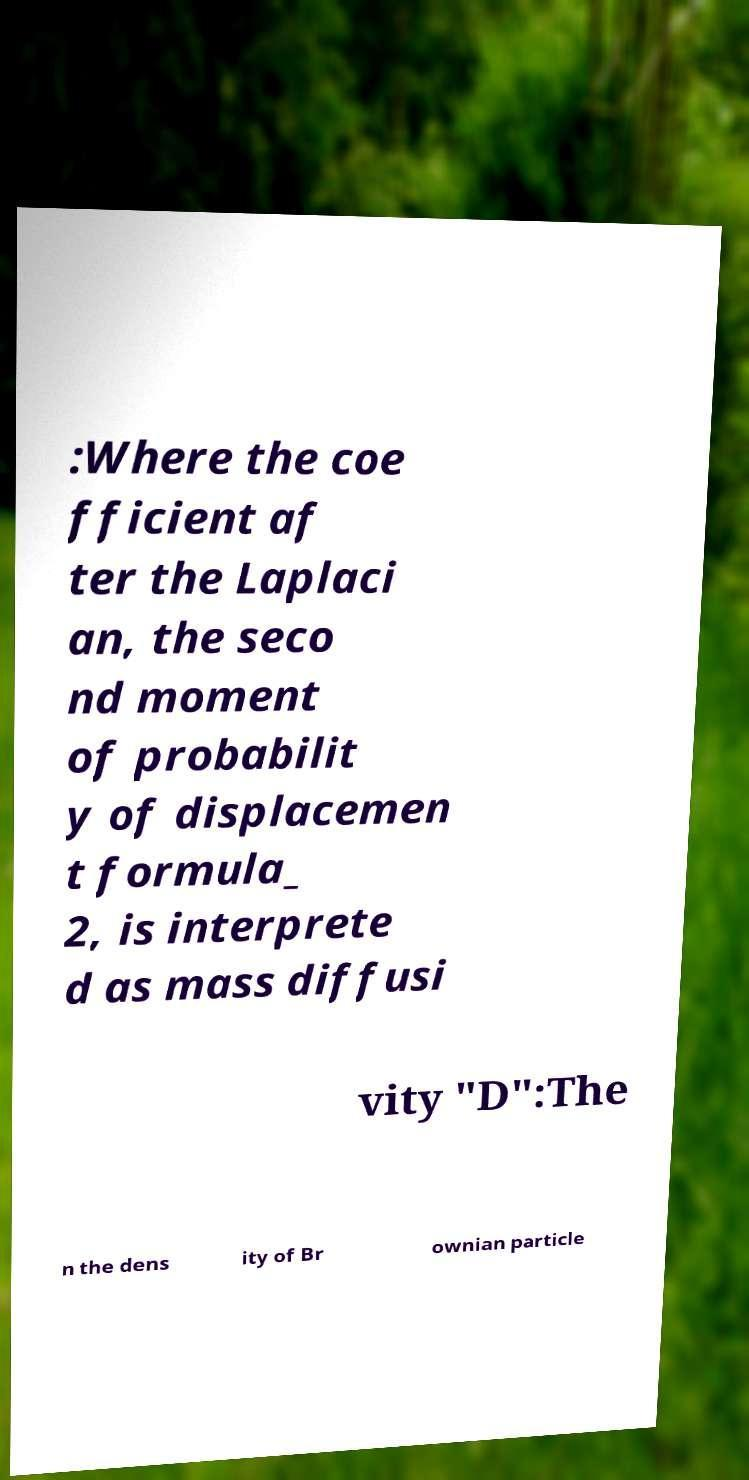Please read and relay the text visible in this image. What does it say? :Where the coe fficient af ter the Laplaci an, the seco nd moment of probabilit y of displacemen t formula_ 2, is interprete d as mass diffusi vity "D":The n the dens ity of Br ownian particle 